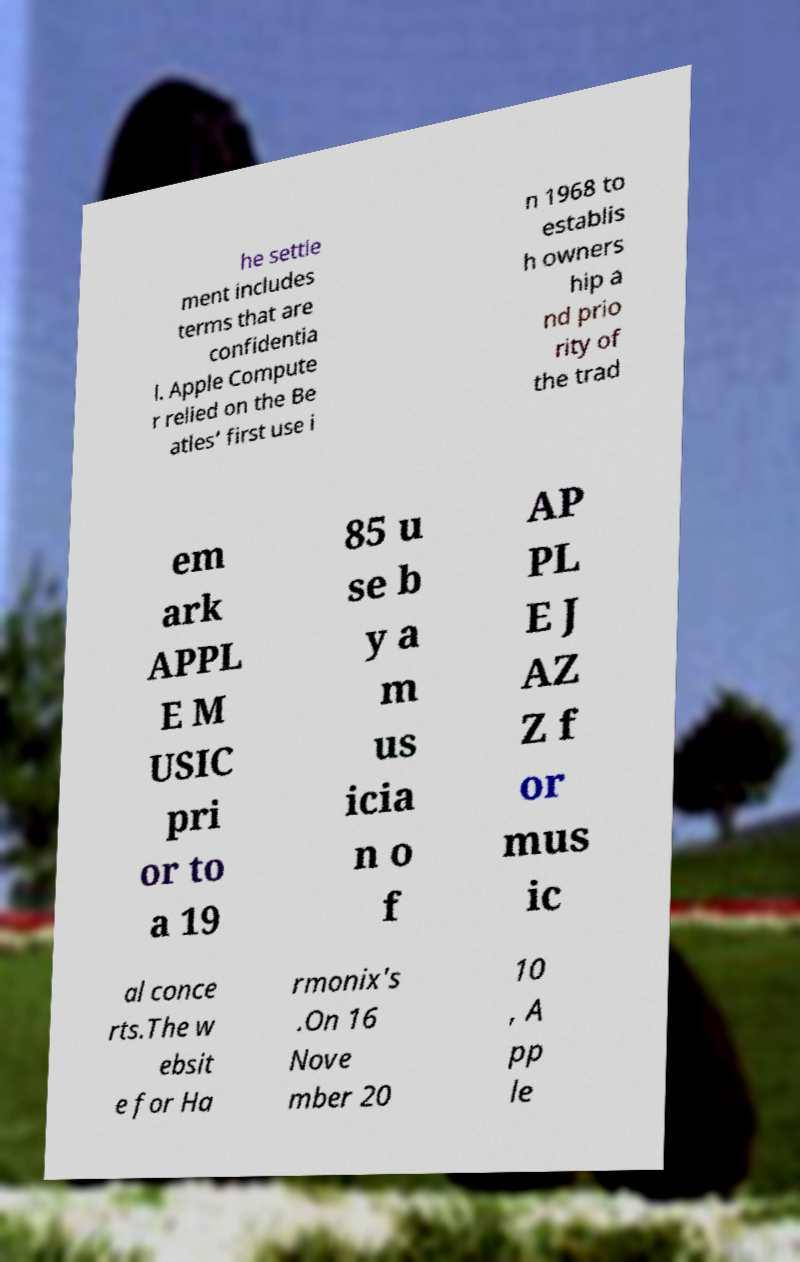Could you assist in decoding the text presented in this image and type it out clearly? he settle ment includes terms that are confidentia l. Apple Compute r relied on the Be atles’ first use i n 1968 to establis h owners hip a nd prio rity of the trad em ark APPL E M USIC pri or to a 19 85 u se b y a m us icia n o f AP PL E J AZ Z f or mus ic al conce rts.The w ebsit e for Ha rmonix's .On 16 Nove mber 20 10 , A pp le 